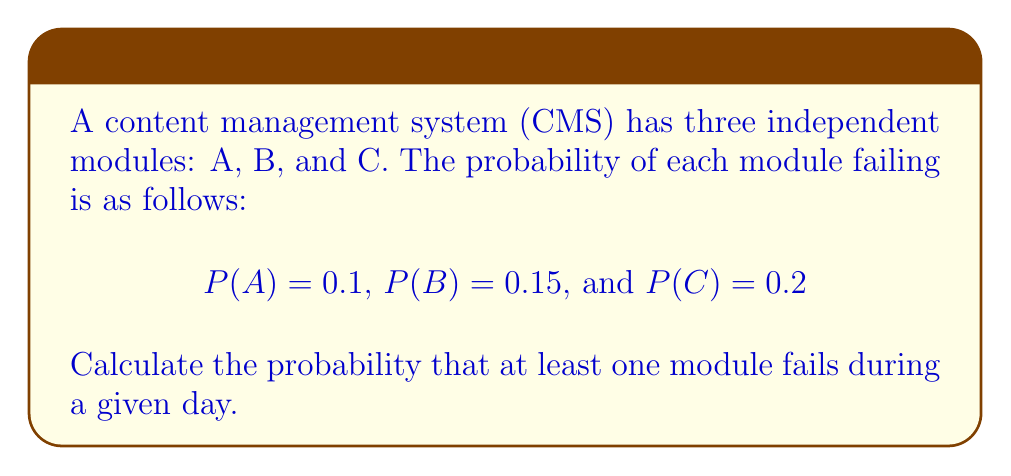Help me with this question. To solve this problem, we'll use Boolean algebra and the concept of complementary events.

1. Let's define the event "at least one module fails" as $F$.
2. The complement of $F$ is the event that no modules fail, which we'll call $\bar{F}$.

3. We can calculate $P(\bar{F})$ as the probability that all modules work correctly:
   $$P(\bar{F}) = P(\bar{A} \wedge \bar{B} \wedge \bar{C})$$

4. Since the modules are independent, we can multiply their individual probabilities:
   $$P(\bar{F}) = P(\bar{A}) \cdot P(\bar{B}) \cdot P(\bar{C})$$

5. For each module, the probability of not failing is the complement of failing:
   $$P(\bar{A}) = 1 - P(A) = 1 - 0.1 = 0.9$$
   $$P(\bar{B}) = 1 - P(B) = 1 - 0.15 = 0.85$$
   $$P(\bar{C}) = 1 - P(C) = 1 - 0.2 = 0.8$$

6. Now we can calculate $P(\bar{F})$:
   $$P(\bar{F}) = 0.9 \cdot 0.85 \cdot 0.8 = 0.612$$

7. Finally, we can find $P(F)$ using the complement rule:
   $$P(F) = 1 - P(\bar{F}) = 1 - 0.612 = 0.388$$

Therefore, the probability that at least one module fails during a given day is 0.388 or 38.8%.
Answer: 0.388 or 38.8% 